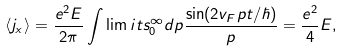Convert formula to latex. <formula><loc_0><loc_0><loc_500><loc_500>\langle j _ { x } \rangle = \frac { e ^ { 2 } E } { 2 \pi } \int \lim i t s _ { 0 } ^ { \infty } d p \frac { \sin ( 2 v _ { F } p t / \hbar { ) } } { p } = \frac { e ^ { 2 } } { 4 } E ,</formula> 